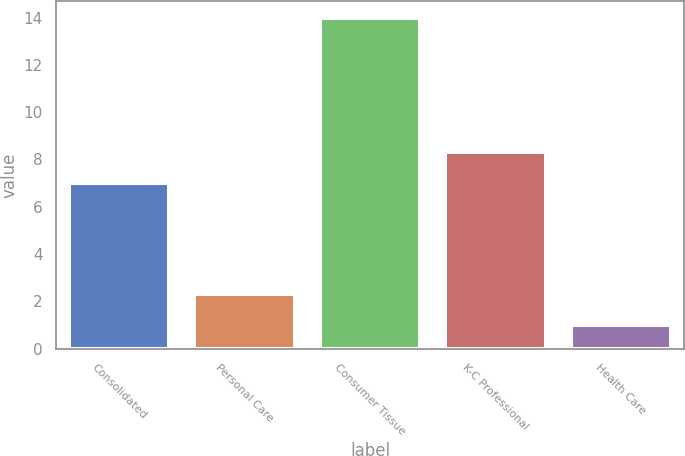Convert chart. <chart><loc_0><loc_0><loc_500><loc_500><bar_chart><fcel>Consolidated<fcel>Personal Care<fcel>Consumer Tissue<fcel>K-C Professional<fcel>Health Care<nl><fcel>7<fcel>2.3<fcel>14<fcel>8.3<fcel>1<nl></chart> 